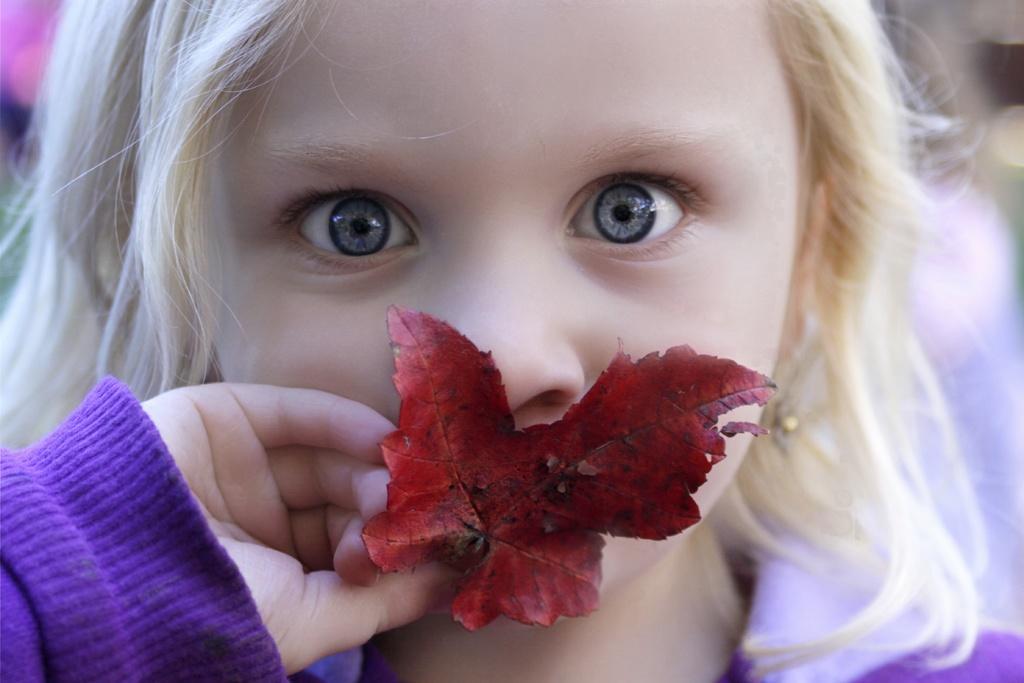Describe this image in one or two sentences. In this image, we can see a girl is watching and holding a leaf. Background there is a blur view. 